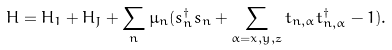Convert formula to latex. <formula><loc_0><loc_0><loc_500><loc_500>H = H _ { 1 } + H _ { J } + \sum _ { n } \mu _ { n } ( s _ { n } ^ { \dagger } s _ { n } + \sum _ { \alpha = x , y , z } t _ { n , \alpha } t _ { n , \alpha } ^ { \dagger } - 1 ) .</formula> 